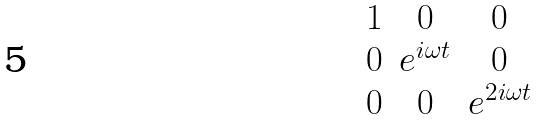<formula> <loc_0><loc_0><loc_500><loc_500>\begin{matrix} 1 & 0 & 0 \\ 0 & e ^ { i \omega t } & 0 \\ 0 & 0 & e ^ { 2 i \omega t } \end{matrix}</formula> 